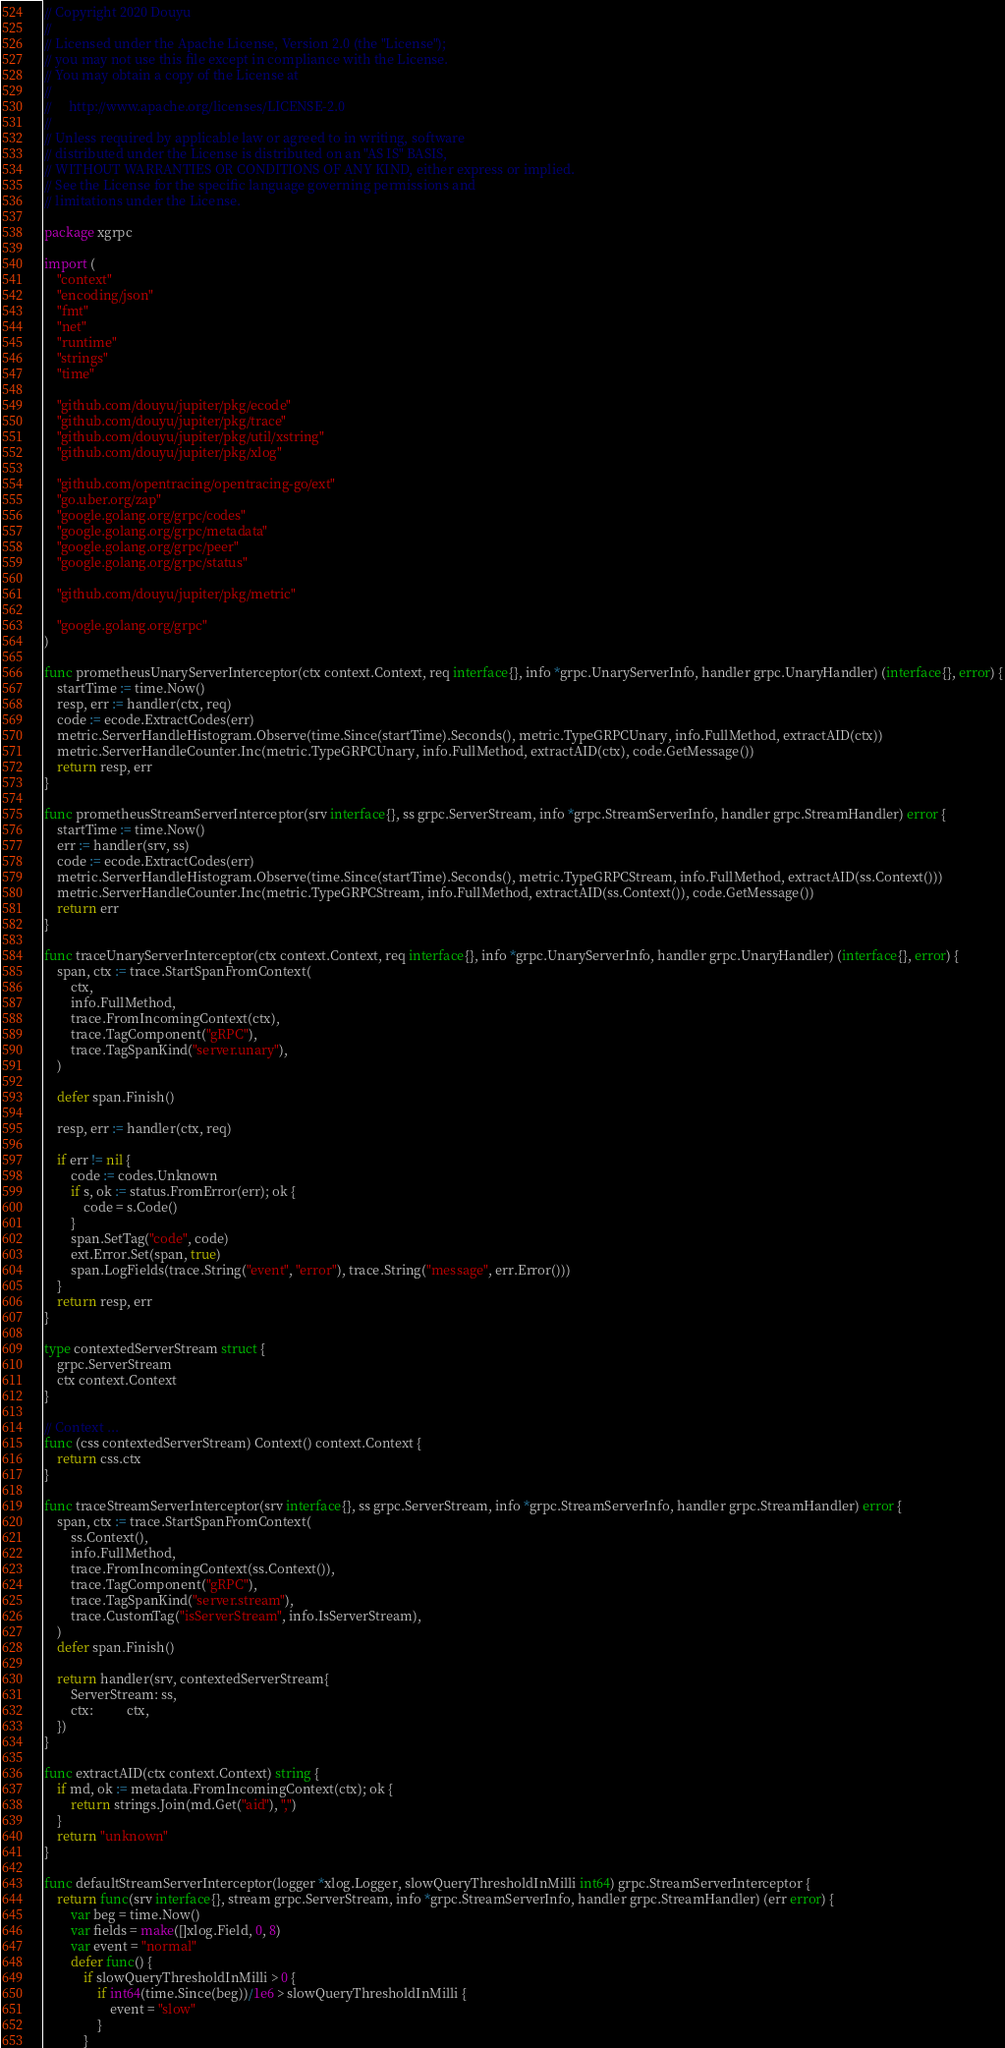Convert code to text. <code><loc_0><loc_0><loc_500><loc_500><_Go_>// Copyright 2020 Douyu
//
// Licensed under the Apache License, Version 2.0 (the "License");
// you may not use this file except in compliance with the License.
// You may obtain a copy of the License at
//
//     http://www.apache.org/licenses/LICENSE-2.0
//
// Unless required by applicable law or agreed to in writing, software
// distributed under the License is distributed on an "AS IS" BASIS,
// WITHOUT WARRANTIES OR CONDITIONS OF ANY KIND, either express or implied.
// See the License for the specific language governing permissions and
// limitations under the License.

package xgrpc

import (
	"context"
	"encoding/json"
	"fmt"
	"net"
	"runtime"
	"strings"
	"time"

	"github.com/douyu/jupiter/pkg/ecode"
	"github.com/douyu/jupiter/pkg/trace"
	"github.com/douyu/jupiter/pkg/util/xstring"
	"github.com/douyu/jupiter/pkg/xlog"

	"github.com/opentracing/opentracing-go/ext"
	"go.uber.org/zap"
	"google.golang.org/grpc/codes"
	"google.golang.org/grpc/metadata"
	"google.golang.org/grpc/peer"
	"google.golang.org/grpc/status"

	"github.com/douyu/jupiter/pkg/metric"

	"google.golang.org/grpc"
)

func prometheusUnaryServerInterceptor(ctx context.Context, req interface{}, info *grpc.UnaryServerInfo, handler grpc.UnaryHandler) (interface{}, error) {
	startTime := time.Now()
	resp, err := handler(ctx, req)
	code := ecode.ExtractCodes(err)
	metric.ServerHandleHistogram.Observe(time.Since(startTime).Seconds(), metric.TypeGRPCUnary, info.FullMethod, extractAID(ctx))
	metric.ServerHandleCounter.Inc(metric.TypeGRPCUnary, info.FullMethod, extractAID(ctx), code.GetMessage())
	return resp, err
}

func prometheusStreamServerInterceptor(srv interface{}, ss grpc.ServerStream, info *grpc.StreamServerInfo, handler grpc.StreamHandler) error {
	startTime := time.Now()
	err := handler(srv, ss)
	code := ecode.ExtractCodes(err)
	metric.ServerHandleHistogram.Observe(time.Since(startTime).Seconds(), metric.TypeGRPCStream, info.FullMethod, extractAID(ss.Context()))
	metric.ServerHandleCounter.Inc(metric.TypeGRPCStream, info.FullMethod, extractAID(ss.Context()), code.GetMessage())
	return err
}

func traceUnaryServerInterceptor(ctx context.Context, req interface{}, info *grpc.UnaryServerInfo, handler grpc.UnaryHandler) (interface{}, error) {
	span, ctx := trace.StartSpanFromContext(
		ctx,
		info.FullMethod,
		trace.FromIncomingContext(ctx),
		trace.TagComponent("gRPC"),
		trace.TagSpanKind("server.unary"),
	)

	defer span.Finish()

	resp, err := handler(ctx, req)

	if err != nil {
		code := codes.Unknown
		if s, ok := status.FromError(err); ok {
			code = s.Code()
		}
		span.SetTag("code", code)
		ext.Error.Set(span, true)
		span.LogFields(trace.String("event", "error"), trace.String("message", err.Error()))
	}
	return resp, err
}

type contextedServerStream struct {
	grpc.ServerStream
	ctx context.Context
}

// Context ...
func (css contextedServerStream) Context() context.Context {
	return css.ctx
}

func traceStreamServerInterceptor(srv interface{}, ss grpc.ServerStream, info *grpc.StreamServerInfo, handler grpc.StreamHandler) error {
	span, ctx := trace.StartSpanFromContext(
		ss.Context(),
		info.FullMethod,
		trace.FromIncomingContext(ss.Context()),
		trace.TagComponent("gRPC"),
		trace.TagSpanKind("server.stream"),
		trace.CustomTag("isServerStream", info.IsServerStream),
	)
	defer span.Finish()

	return handler(srv, contextedServerStream{
		ServerStream: ss,
		ctx:          ctx,
	})
}

func extractAID(ctx context.Context) string {
	if md, ok := metadata.FromIncomingContext(ctx); ok {
		return strings.Join(md.Get("aid"), ",")
	}
	return "unknown"
}

func defaultStreamServerInterceptor(logger *xlog.Logger, slowQueryThresholdInMilli int64) grpc.StreamServerInterceptor {
	return func(srv interface{}, stream grpc.ServerStream, info *grpc.StreamServerInfo, handler grpc.StreamHandler) (err error) {
		var beg = time.Now()
		var fields = make([]xlog.Field, 0, 8)
		var event = "normal"
		defer func() {
			if slowQueryThresholdInMilli > 0 {
				if int64(time.Since(beg))/1e6 > slowQueryThresholdInMilli {
					event = "slow"
				}
			}
</code> 